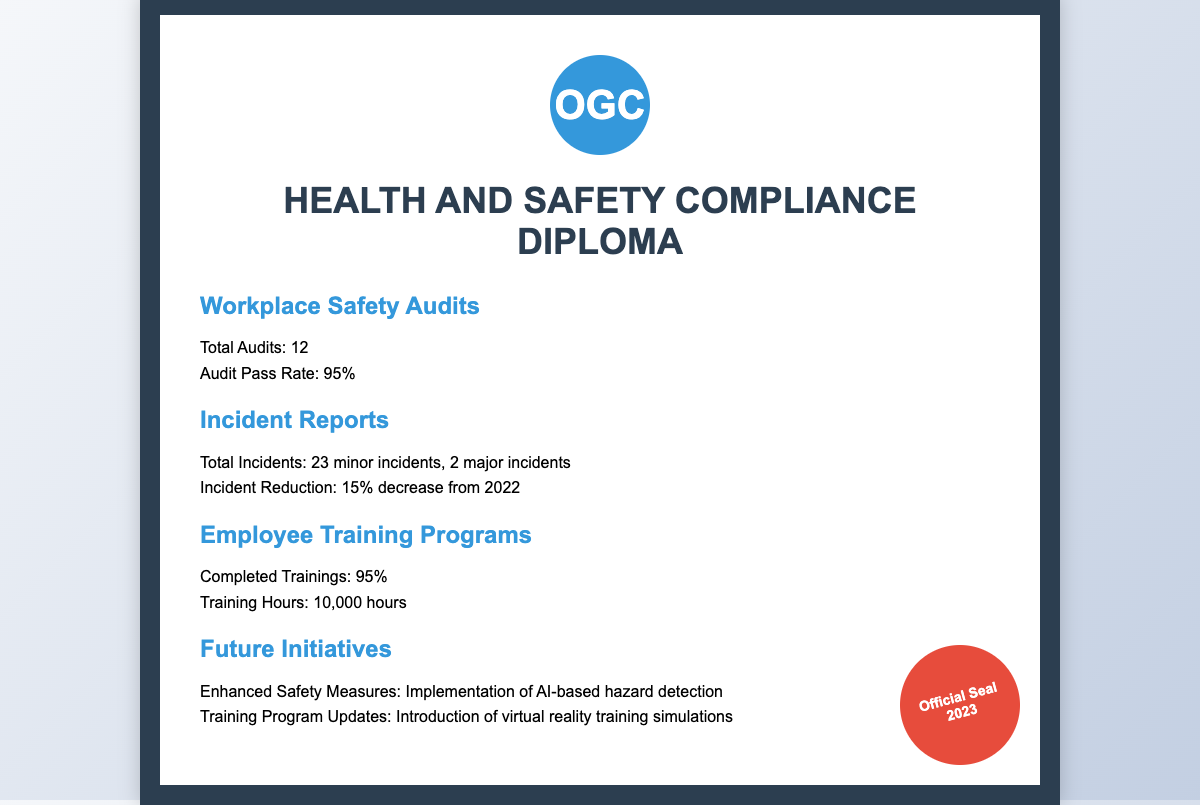what is the total number of workplace safety audits? The document states that there were a total of 12 workplace safety audits conducted.
Answer: 12 what is the audit pass rate? The audit pass rate is mentioned as 95%.
Answer: 95% how many major incidents were reported? According to the document, there were 2 major incidents reported.
Answer: 2 by what percentage did incidents decrease from 2022? The document indicates a 15% decrease in incidents compared to 2022.
Answer: 15% what percentage of employee training programs was completed? The completion rate for employee training programs is noted as 95%.
Answer: 95% what technology will be implemented for enhanced safety measures? The document mentions the implementation of AI-based hazard detection as part of enhanced safety measures.
Answer: AI-based hazard detection how many training hours were completed? It is stated in the document that 10,000 training hours were completed.
Answer: 10,000 what is a future initiative related to employee training? The document specifies that the introduction of virtual reality training simulations is a future training initiative.
Answer: virtual reality training simulations how many total incidents were reported? The document outlines 23 minor incidents and 2 major incidents, summing up to 25 total incidents.
Answer: 25 